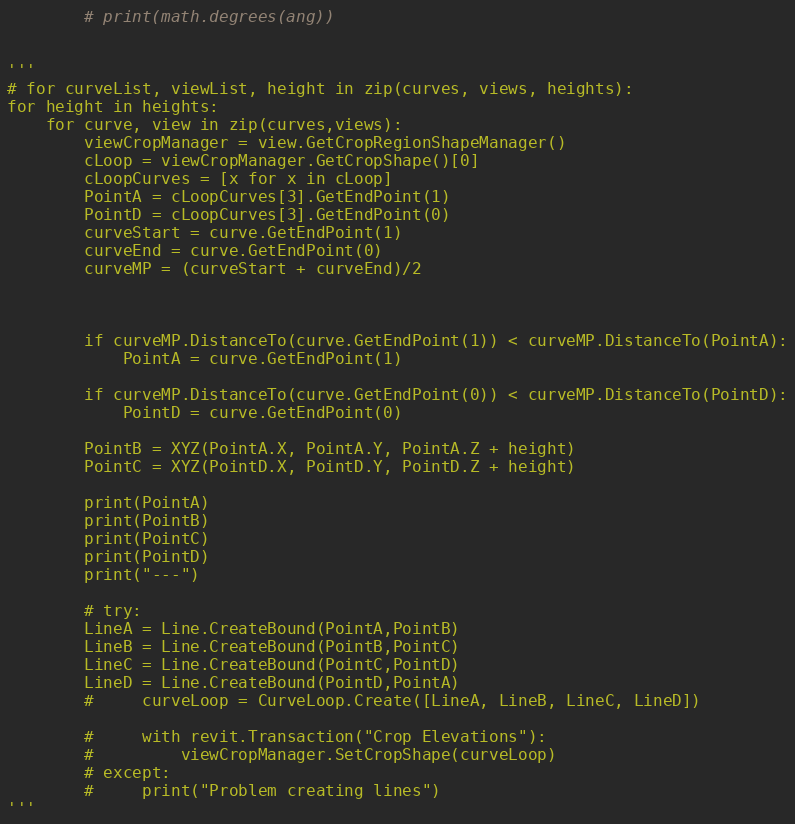<code> <loc_0><loc_0><loc_500><loc_500><_Python_>        # print(math.degrees(ang))

        
'''
# for curveList, viewList, height in zip(curves, views, heights):
for height in heights:
    for curve, view in zip(curves,views):
        viewCropManager = view.GetCropRegionShapeManager()
        cLoop = viewCropManager.GetCropShape()[0]
        cLoopCurves = [x for x in cLoop]
        PointA = cLoopCurves[3].GetEndPoint(1)
        PointD = cLoopCurves[3].GetEndPoint(0)
        curveStart = curve.GetEndPoint(1)
        curveEnd = curve.GetEndPoint(0)
        curveMP = (curveStart + curveEnd)/2
        


        if curveMP.DistanceTo(curve.GetEndPoint(1)) < curveMP.DistanceTo(PointA):
            PointA = curve.GetEndPoint(1)		
            
        if curveMP.DistanceTo(curve.GetEndPoint(0)) < curveMP.DistanceTo(PointD):
            PointD = curve.GetEndPoint(0)			

        PointB = XYZ(PointA.X, PointA.Y, PointA.Z + height)
        PointC = XYZ(PointD.X, PointD.Y, PointD.Z + height)

        print(PointA)
        print(PointB)
        print(PointC)
        print(PointD)
        print("---")

        # try:
        LineA = Line.CreateBound(PointA,PointB)
        LineB = Line.CreateBound(PointB,PointC)
        LineC = Line.CreateBound(PointC,PointD)
        LineD = Line.CreateBound(PointD,PointA)
        #     curveLoop = CurveLoop.Create([LineA, LineB, LineC, LineD])

        #     with revit.Transaction("Crop Elevations"):		
        #         viewCropManager.SetCropShape(curveLoop)
        # except:
        #     print("Problem creating lines")
'''</code> 